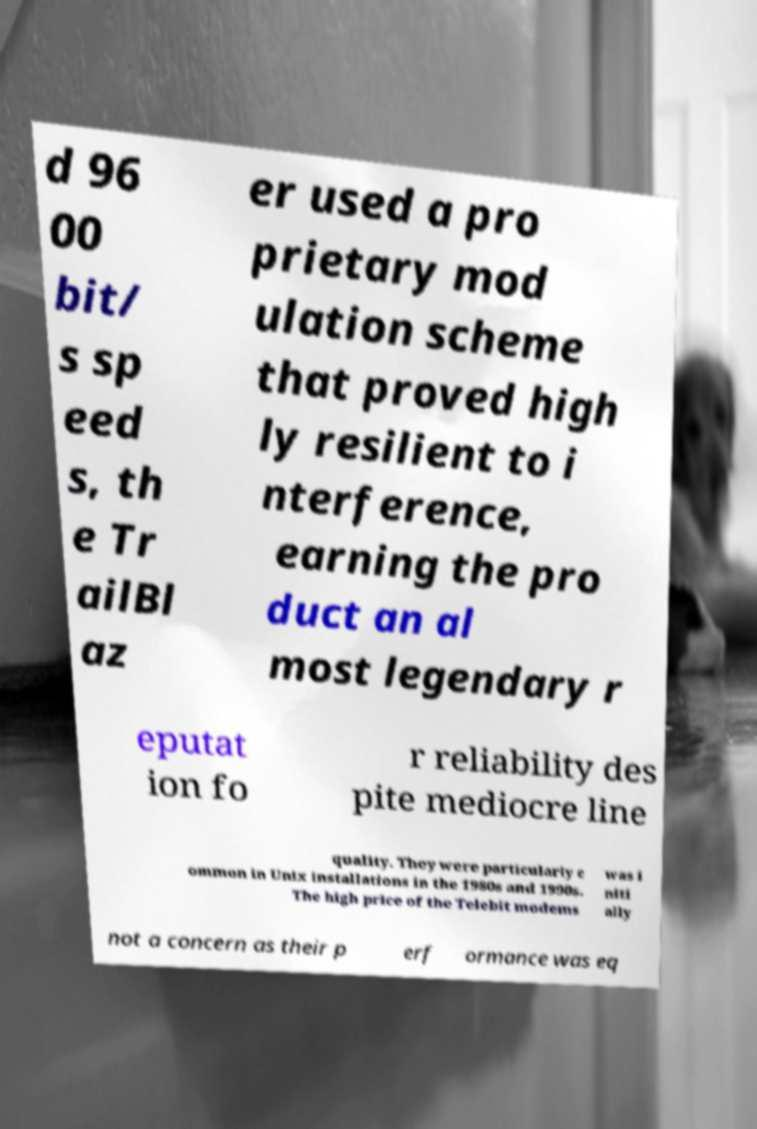Can you accurately transcribe the text from the provided image for me? d 96 00 bit/ s sp eed s, th e Tr ailBl az er used a pro prietary mod ulation scheme that proved high ly resilient to i nterference, earning the pro duct an al most legendary r eputat ion fo r reliability des pite mediocre line quality. They were particularly c ommon in Unix installations in the 1980s and 1990s. The high price of the Telebit modems was i niti ally not a concern as their p erf ormance was eq 